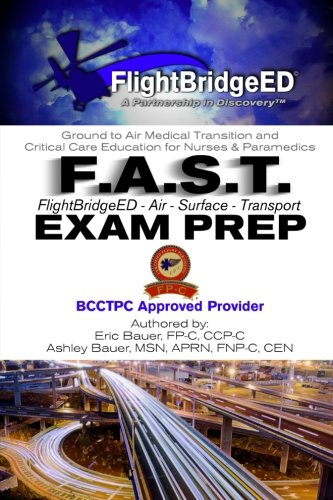Who is the author of this book? The book is co-authored by Eric R. Bauer and Ashley Bauer, both of whom bring specialized expertise in medical emergency transport and education. 